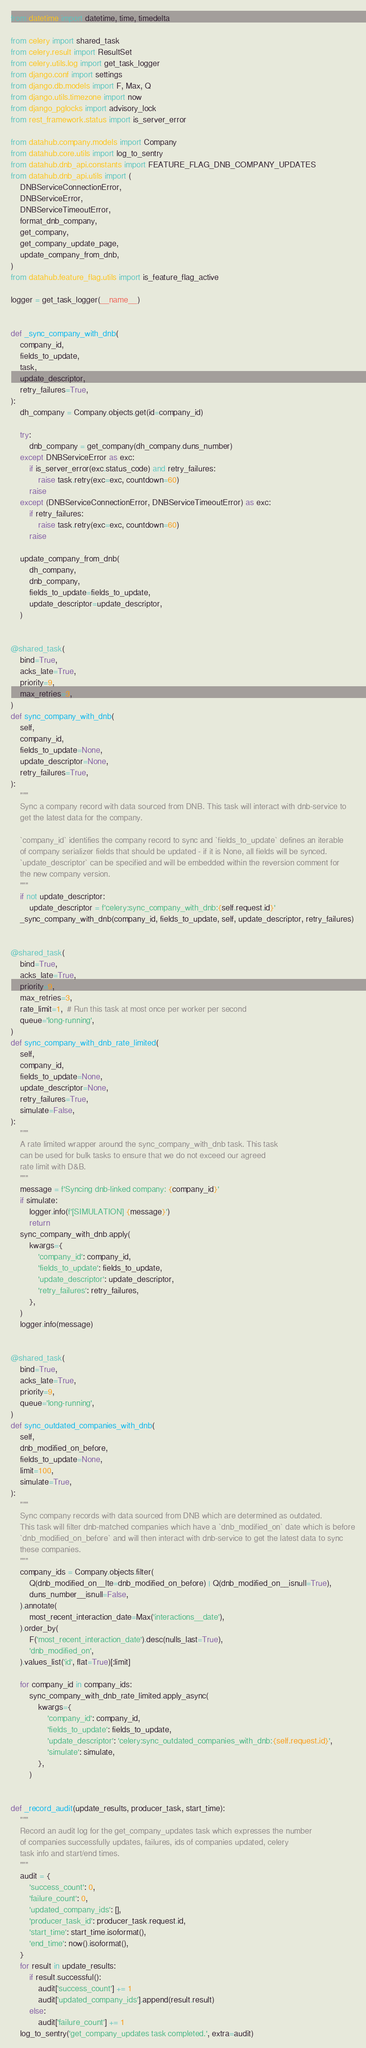Convert code to text. <code><loc_0><loc_0><loc_500><loc_500><_Python_>from datetime import datetime, time, timedelta

from celery import shared_task
from celery.result import ResultSet
from celery.utils.log import get_task_logger
from django.conf import settings
from django.db.models import F, Max, Q
from django.utils.timezone import now
from django_pglocks import advisory_lock
from rest_framework.status import is_server_error

from datahub.company.models import Company
from datahub.core.utils import log_to_sentry
from datahub.dnb_api.constants import FEATURE_FLAG_DNB_COMPANY_UPDATES
from datahub.dnb_api.utils import (
    DNBServiceConnectionError,
    DNBServiceError,
    DNBServiceTimeoutError,
    format_dnb_company,
    get_company,
    get_company_update_page,
    update_company_from_dnb,
)
from datahub.feature_flag.utils import is_feature_flag_active

logger = get_task_logger(__name__)


def _sync_company_with_dnb(
    company_id,
    fields_to_update,
    task,
    update_descriptor,
    retry_failures=True,
):
    dh_company = Company.objects.get(id=company_id)

    try:
        dnb_company = get_company(dh_company.duns_number)
    except DNBServiceError as exc:
        if is_server_error(exc.status_code) and retry_failures:
            raise task.retry(exc=exc, countdown=60)
        raise
    except (DNBServiceConnectionError, DNBServiceTimeoutError) as exc:
        if retry_failures:
            raise task.retry(exc=exc, countdown=60)
        raise

    update_company_from_dnb(
        dh_company,
        dnb_company,
        fields_to_update=fields_to_update,
        update_descriptor=update_descriptor,
    )


@shared_task(
    bind=True,
    acks_late=True,
    priority=9,
    max_retries=3,
)
def sync_company_with_dnb(
    self,
    company_id,
    fields_to_update=None,
    update_descriptor=None,
    retry_failures=True,
):
    """
    Sync a company record with data sourced from DNB. This task will interact with dnb-service to
    get the latest data for the company.

    `company_id` identifies the company record to sync and `fields_to_update` defines an iterable
    of company serializer fields that should be updated - if it is None, all fields will be synced.
    `update_descriptor` can be specified and will be embedded within the reversion comment for
    the new company version.
    """
    if not update_descriptor:
        update_descriptor = f'celery:sync_company_with_dnb:{self.request.id}'
    _sync_company_with_dnb(company_id, fields_to_update, self, update_descriptor, retry_failures)


@shared_task(
    bind=True,
    acks_late=True,
    priority=9,
    max_retries=3,
    rate_limit=1,  # Run this task at most once per worker per second
    queue='long-running',
)
def sync_company_with_dnb_rate_limited(
    self,
    company_id,
    fields_to_update=None,
    update_descriptor=None,
    retry_failures=True,
    simulate=False,
):
    """
    A rate limited wrapper around the sync_company_with_dnb task. This task
    can be used for bulk tasks to ensure that we do not exceed our agreed
    rate limit with D&B.
    """
    message = f'Syncing dnb-linked company: {company_id}'
    if simulate:
        logger.info(f'[SIMULATION] {message}')
        return
    sync_company_with_dnb.apply(
        kwargs={
            'company_id': company_id,
            'fields_to_update': fields_to_update,
            'update_descriptor': update_descriptor,
            'retry_failures': retry_failures,
        },
    )
    logger.info(message)


@shared_task(
    bind=True,
    acks_late=True,
    priority=9,
    queue='long-running',
)
def sync_outdated_companies_with_dnb(
    self,
    dnb_modified_on_before,
    fields_to_update=None,
    limit=100,
    simulate=True,
):
    """
    Sync company records with data sourced from DNB which are determined as outdated.
    This task will filter dnb-matched companies which have a `dnb_modified_on` date which is before
    `dnb_modified_on_before` and will then interact with dnb-service to get the latest data to sync
    these companies.
    """
    company_ids = Company.objects.filter(
        Q(dnb_modified_on__lte=dnb_modified_on_before) | Q(dnb_modified_on__isnull=True),
        duns_number__isnull=False,
    ).annotate(
        most_recent_interaction_date=Max('interactions__date'),
    ).order_by(
        F('most_recent_interaction_date').desc(nulls_last=True),
        'dnb_modified_on',
    ).values_list('id', flat=True)[:limit]

    for company_id in company_ids:
        sync_company_with_dnb_rate_limited.apply_async(
            kwargs={
                'company_id': company_id,
                'fields_to_update': fields_to_update,
                'update_descriptor': 'celery:sync_outdated_companies_with_dnb:{self.request.id}',
                'simulate': simulate,
            },
        )


def _record_audit(update_results, producer_task, start_time):
    """
    Record an audit log for the get_company_updates task which expresses the number
    of companies successfully updates, failures, ids of companies updated, celery
    task info and start/end times.
    """
    audit = {
        'success_count': 0,
        'failure_count': 0,
        'updated_company_ids': [],
        'producer_task_id': producer_task.request.id,
        'start_time': start_time.isoformat(),
        'end_time': now().isoformat(),
    }
    for result in update_results:
        if result.successful():
            audit['success_count'] += 1
            audit['updated_company_ids'].append(result.result)
        else:
            audit['failure_count'] += 1
    log_to_sentry('get_company_updates task completed.', extra=audit)

</code> 